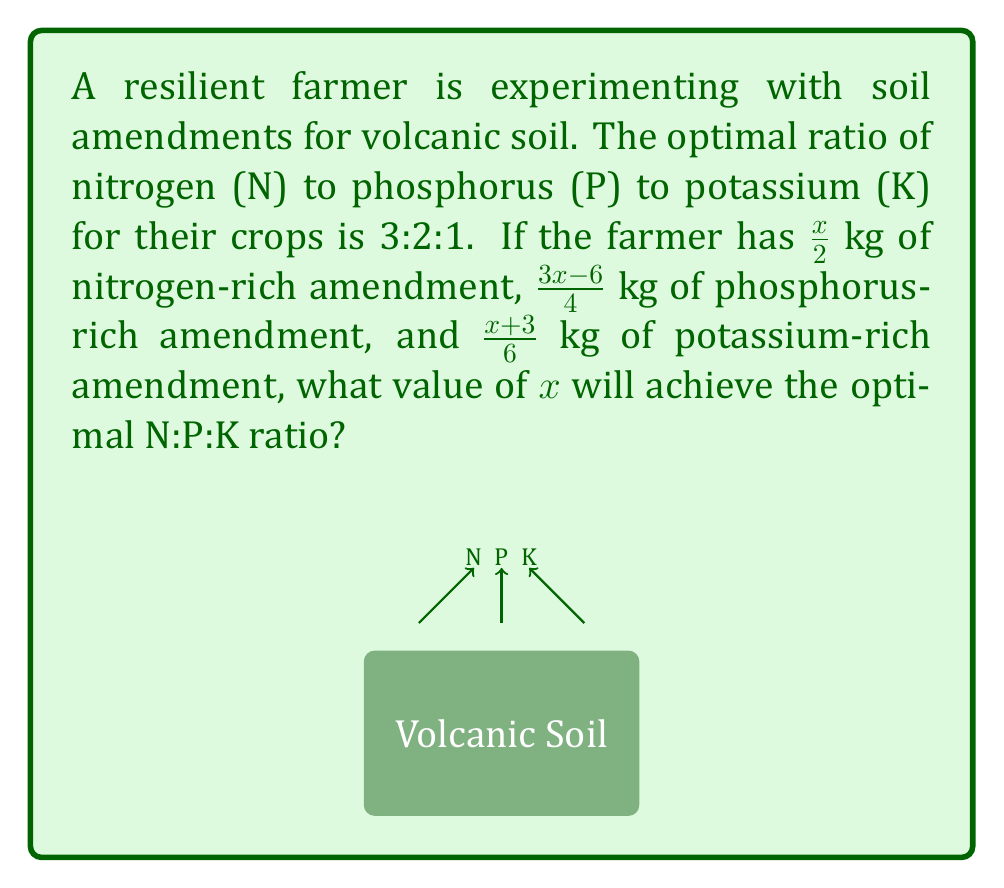Can you answer this question? Let's approach this step-by-step:

1) First, we need to set up equations based on the optimal ratio 3:2:1 for N:P:K.

2) Let's denote the amount of each nutrient as:
   N: $\frac{x}{2}$
   P: $\frac{3x-6}{4}$
   K: $\frac{x+3}{6}$

3) For the optimal ratio 3:2:1, we can write:
   $$\frac{N}{3} = \frac{P}{2} = \frac{K}{1}$$

4) Let's start with equating N and P:
   $$\frac{\frac{x}{2}}{3} = \frac{\frac{3x-6}{4}}{2}$$

5) Cross multiply:
   $$2 \cdot \frac{x}{2} = 3 \cdot \frac{3x-6}{4}$$

6) Simplify:
   $$x = \frac{9x-18}{4}$$

7) Multiply both sides by 4:
   $$4x = 9x-18$$

8) Subtract 9x from both sides:
   $$-5x = -18$$

9) Divide both sides by -5:
   $$x = \frac{18}{5} = 3.6$$

10) Now let's verify if this satisfies the ratio with K:
    $$\frac{\frac{3.6}{2}}{3} = \frac{\frac{3(3.6)-6}{4}}{2} = \frac{\frac{3.6+3}{6}}{1} = 0.6$$

Therefore, when $x = 3.6$, the ratio N:P:K is indeed 3:2:1.
Answer: $x = 3.6$ 